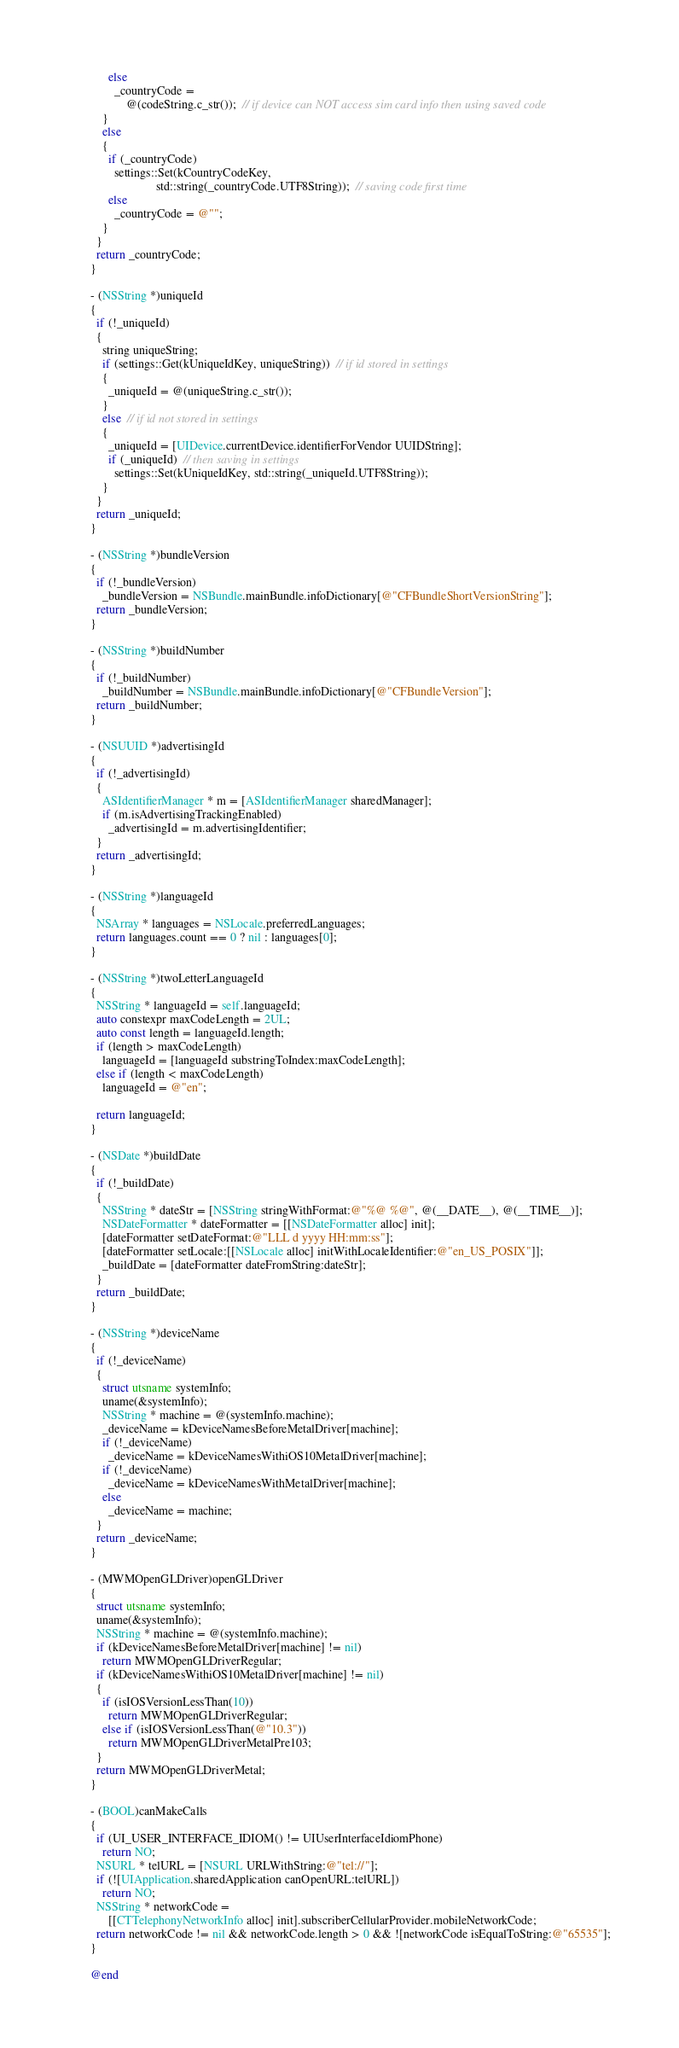Convert code to text. <code><loc_0><loc_0><loc_500><loc_500><_ObjectiveC_>      else
        _countryCode =
            @(codeString.c_str());  // if device can NOT access sim card info then using saved code
    }
    else
    {
      if (_countryCode)
        settings::Set(kCountryCodeKey,
                      std::string(_countryCode.UTF8String));  // saving code first time
      else
        _countryCode = @"";
    }
  }
  return _countryCode;
}

- (NSString *)uniqueId
{
  if (!_uniqueId)
  {
    string uniqueString;
    if (settings::Get(kUniqueIdKey, uniqueString))  // if id stored in settings
    {
      _uniqueId = @(uniqueString.c_str());
    }
    else  // if id not stored in settings
    {
      _uniqueId = [UIDevice.currentDevice.identifierForVendor UUIDString];
      if (_uniqueId)  // then saving in settings
        settings::Set(kUniqueIdKey, std::string(_uniqueId.UTF8String));
    }
  }
  return _uniqueId;
}

- (NSString *)bundleVersion
{
  if (!_bundleVersion)
    _bundleVersion = NSBundle.mainBundle.infoDictionary[@"CFBundleShortVersionString"];
  return _bundleVersion;
}

- (NSString *)buildNumber
{
  if (!_buildNumber)
    _buildNumber = NSBundle.mainBundle.infoDictionary[@"CFBundleVersion"];
  return _buildNumber;
}

- (NSUUID *)advertisingId
{
  if (!_advertisingId)
  {
    ASIdentifierManager * m = [ASIdentifierManager sharedManager];
    if (m.isAdvertisingTrackingEnabled)
      _advertisingId = m.advertisingIdentifier;
  }
  return _advertisingId;
}

- (NSString *)languageId
{
  NSArray * languages = NSLocale.preferredLanguages;
  return languages.count == 0 ? nil : languages[0];
}

- (NSString *)twoLetterLanguageId
{
  NSString * languageId = self.languageId;
  auto constexpr maxCodeLength = 2UL;
  auto const length = languageId.length;
  if (length > maxCodeLength)
    languageId = [languageId substringToIndex:maxCodeLength];
  else if (length < maxCodeLength)
    languageId = @"en";

  return languageId;
}

- (NSDate *)buildDate
{
  if (!_buildDate)
  {
    NSString * dateStr = [NSString stringWithFormat:@"%@ %@", @(__DATE__), @(__TIME__)];
    NSDateFormatter * dateFormatter = [[NSDateFormatter alloc] init];
    [dateFormatter setDateFormat:@"LLL d yyyy HH:mm:ss"];
    [dateFormatter setLocale:[[NSLocale alloc] initWithLocaleIdentifier:@"en_US_POSIX"]];
    _buildDate = [dateFormatter dateFromString:dateStr];
  }
  return _buildDate;
}

- (NSString *)deviceName
{
  if (!_deviceName)
  {
    struct utsname systemInfo;
    uname(&systemInfo);
    NSString * machine = @(systemInfo.machine);
    _deviceName = kDeviceNamesBeforeMetalDriver[machine];
    if (!_deviceName)
      _deviceName = kDeviceNamesWithiOS10MetalDriver[machine];
    if (!_deviceName)
      _deviceName = kDeviceNamesWithMetalDriver[machine];
    else
      _deviceName = machine;
  }
  return _deviceName;
}

- (MWMOpenGLDriver)openGLDriver
{
  struct utsname systemInfo;
  uname(&systemInfo);
  NSString * machine = @(systemInfo.machine);
  if (kDeviceNamesBeforeMetalDriver[machine] != nil)
    return MWMOpenGLDriverRegular;
  if (kDeviceNamesWithiOS10MetalDriver[machine] != nil)
  {
    if (isIOSVersionLessThan(10))
      return MWMOpenGLDriverRegular;
    else if (isIOSVersionLessThan(@"10.3"))
      return MWMOpenGLDriverMetalPre103;
  }
  return MWMOpenGLDriverMetal;
}

- (BOOL)canMakeCalls
{
  if (UI_USER_INTERFACE_IDIOM() != UIUserInterfaceIdiomPhone)
    return NO;
  NSURL * telURL = [NSURL URLWithString:@"tel://"];
  if (![UIApplication.sharedApplication canOpenURL:telURL])
    return NO;
  NSString * networkCode =
      [[CTTelephonyNetworkInfo alloc] init].subscriberCellularProvider.mobileNetworkCode;
  return networkCode != nil && networkCode.length > 0 && ![networkCode isEqualToString:@"65535"];
}

@end
</code> 